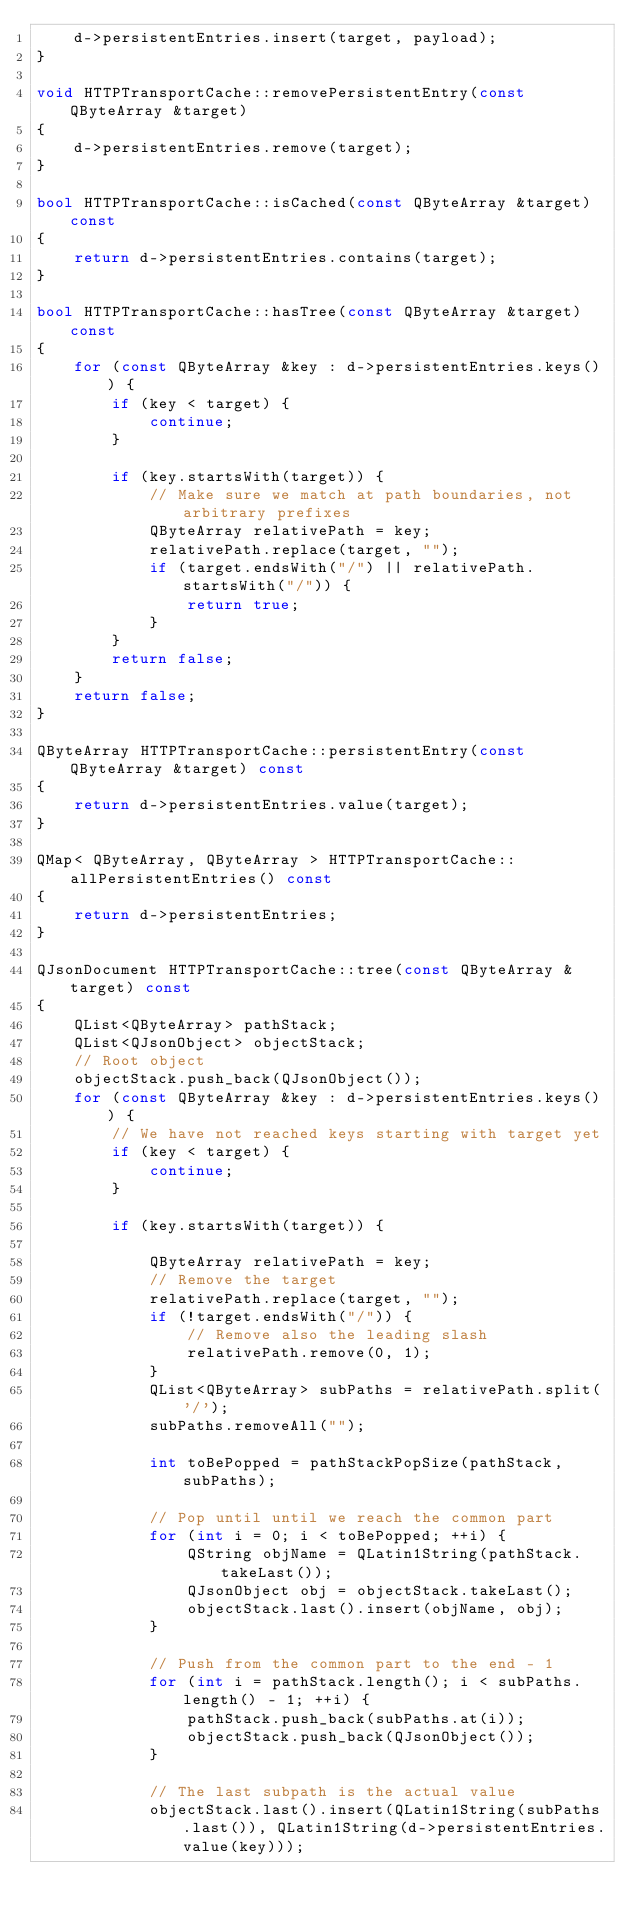<code> <loc_0><loc_0><loc_500><loc_500><_C++_>    d->persistentEntries.insert(target, payload);
}

void HTTPTransportCache::removePersistentEntry(const QByteArray &target)
{
    d->persistentEntries.remove(target);
}

bool HTTPTransportCache::isCached(const QByteArray &target) const
{
    return d->persistentEntries.contains(target);
}

bool HTTPTransportCache::hasTree(const QByteArray &target) const
{
    for (const QByteArray &key : d->persistentEntries.keys()) {
        if (key < target) {
            continue;
        }

        if (key.startsWith(target)) {
            // Make sure we match at path boundaries, not arbitrary prefixes
            QByteArray relativePath = key;
            relativePath.replace(target, "");
            if (target.endsWith("/") || relativePath.startsWith("/")) {
                return true;
            }
        }
        return false;
    }
    return false;
}

QByteArray HTTPTransportCache::persistentEntry(const QByteArray &target) const
{
    return d->persistentEntries.value(target);
}

QMap< QByteArray, QByteArray > HTTPTransportCache::allPersistentEntries() const
{
    return d->persistentEntries;
}

QJsonDocument HTTPTransportCache::tree(const QByteArray &target) const
{
    QList<QByteArray> pathStack;
    QList<QJsonObject> objectStack;
    // Root object
    objectStack.push_back(QJsonObject());
    for (const QByteArray &key : d->persistentEntries.keys()) {
        // We have not reached keys starting with target yet
        if (key < target) {
            continue;
        }

        if (key.startsWith(target)) {

            QByteArray relativePath = key;
            // Remove the target
            relativePath.replace(target, "");
            if (!target.endsWith("/")) {
                // Remove also the leading slash
                relativePath.remove(0, 1);
            }
            QList<QByteArray> subPaths = relativePath.split('/');
            subPaths.removeAll("");

            int toBePopped = pathStackPopSize(pathStack, subPaths);

            // Pop until until we reach the common part
            for (int i = 0; i < toBePopped; ++i) {
                QString objName = QLatin1String(pathStack.takeLast());
                QJsonObject obj = objectStack.takeLast();
                objectStack.last().insert(objName, obj);
            }

            // Push from the common part to the end - 1
            for (int i = pathStack.length(); i < subPaths.length() - 1; ++i) {
                pathStack.push_back(subPaths.at(i));
                objectStack.push_back(QJsonObject());
            }

            // The last subpath is the actual value
            objectStack.last().insert(QLatin1String(subPaths.last()), QLatin1String(d->persistentEntries.value(key)));
</code> 